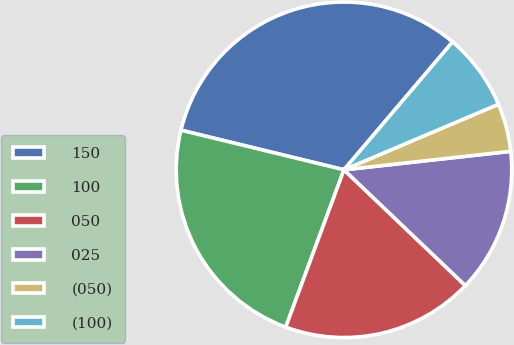Convert chart. <chart><loc_0><loc_0><loc_500><loc_500><pie_chart><fcel>150<fcel>100<fcel>050<fcel>025<fcel>(050)<fcel>(100)<nl><fcel>32.41%<fcel>23.15%<fcel>18.52%<fcel>13.88%<fcel>4.63%<fcel>7.41%<nl></chart> 